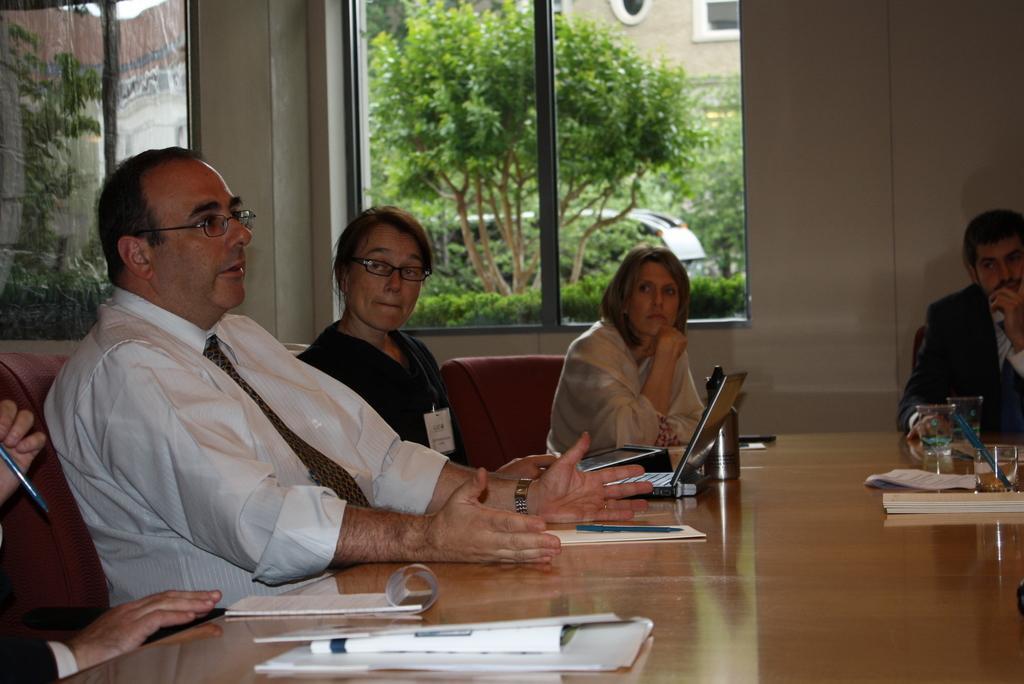In one or two sentences, can you explain what this image depicts? This image is taken inside the room. In the middle of the image there is a table which has a book, papers, pen, laptop, flask, a glass with water, mobile phone. In the left side of the image a person is sitting on a chair. In the right side of the image a person is sitting on a chair placing his hand on a table. In the middle of the image a woman is sitting on a chair. In this image there is a wall with a window. At the background there is a tree along with small plants and a vehicle. 